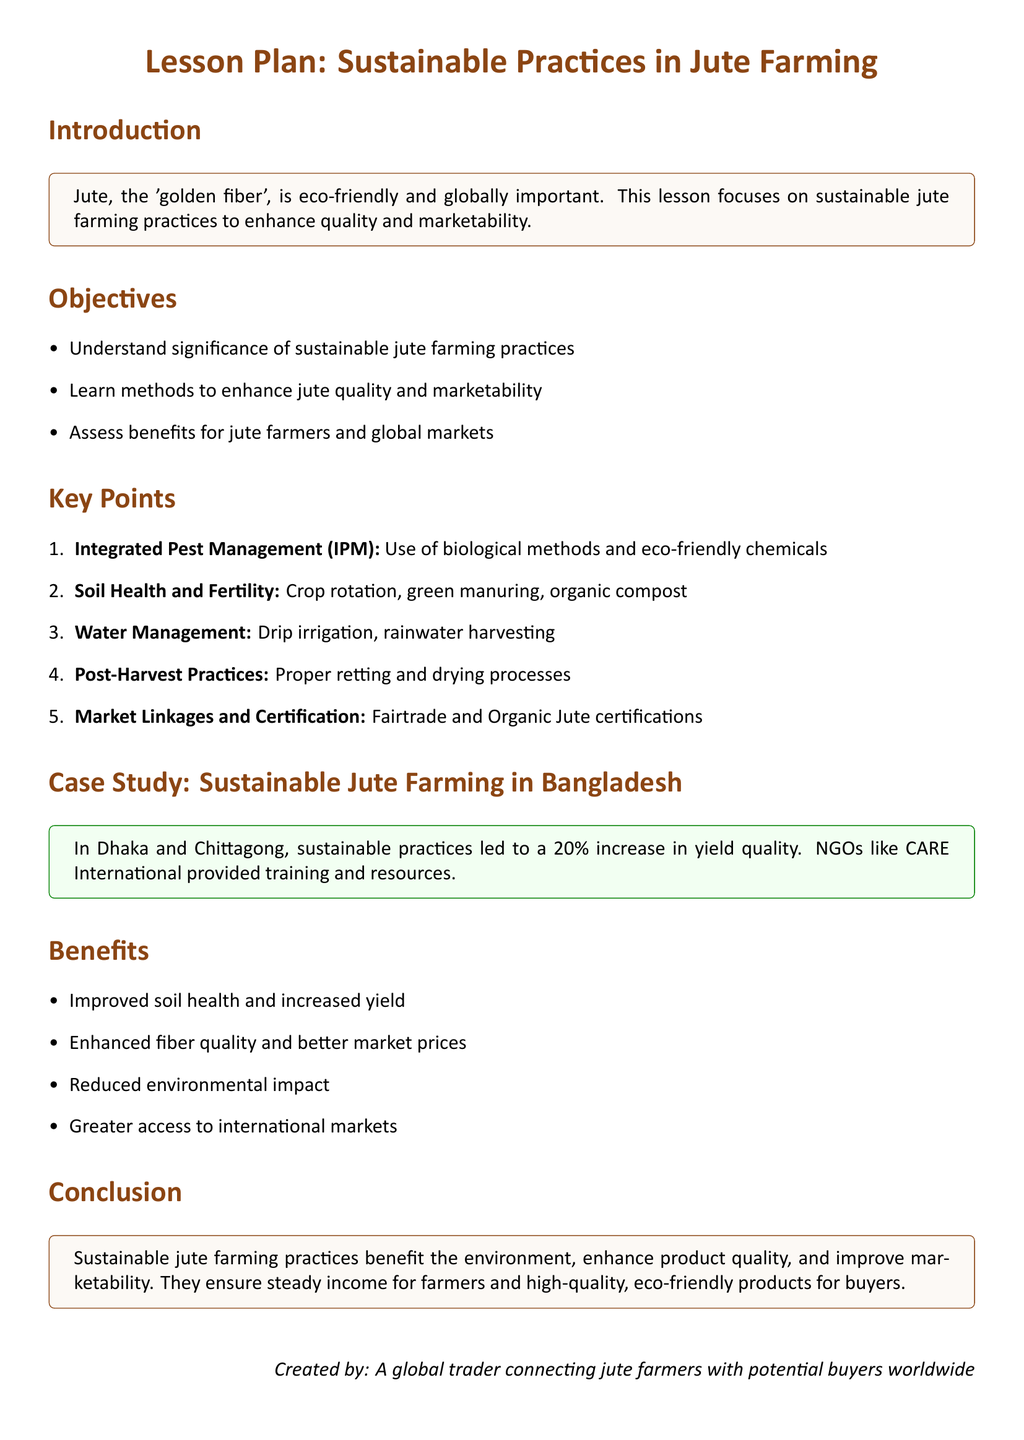What is the primary focus of the lesson plan? The primary focus is on sustainable jute farming practices to enhance quality and marketability.
Answer: Sustainable jute farming practices What percentage increase in yield quality was reported in the case study? The document states that sustainable practices led to a 20% increase in yield quality.
Answer: 20% What is one method mentioned for improving soil health and fertility? The document lists crop rotation, green manuring, and organic compost as methods for improving soil health and fertility.
Answer: Crop rotation What are two certifications mentioned for market linkages? Fairtrade and Organic Jute certifications are specified in the document as important for market linkages.
Answer: Fairtrade and Organic Jute Who provided training and resources in the case study of sustainable jute farming? The document indicates that NGOs like CARE International provided training and resources.
Answer: CARE International What is one benefit listed for jute farmers from sustainable practices? The document highlights improved soil health and increased yield as a benefit for jute farmers.
Answer: Improved soil health What is the conclusion of the lesson plan regarding sustainable practices? The conclusion emphasizes that sustainable jute farming practices benefit the environment and enhance product quality.
Answer: Benefit the environment and enhance product quality What is the main type of irrigation mentioned in the document? The lesson plan mentions drip irrigation as a method of water management.
Answer: Drip irrigation What color theme is used for the title of the document? The title uses a brown color theme, as indicated in the document.
Answer: Brown 